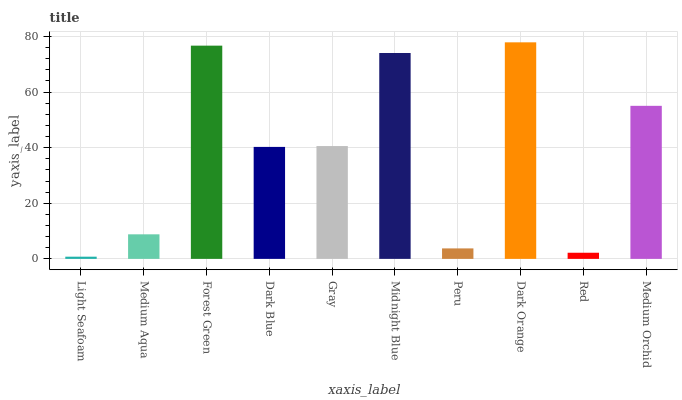Is Light Seafoam the minimum?
Answer yes or no. Yes. Is Dark Orange the maximum?
Answer yes or no. Yes. Is Medium Aqua the minimum?
Answer yes or no. No. Is Medium Aqua the maximum?
Answer yes or no. No. Is Medium Aqua greater than Light Seafoam?
Answer yes or no. Yes. Is Light Seafoam less than Medium Aqua?
Answer yes or no. Yes. Is Light Seafoam greater than Medium Aqua?
Answer yes or no. No. Is Medium Aqua less than Light Seafoam?
Answer yes or no. No. Is Gray the high median?
Answer yes or no. Yes. Is Dark Blue the low median?
Answer yes or no. Yes. Is Medium Aqua the high median?
Answer yes or no. No. Is Gray the low median?
Answer yes or no. No. 